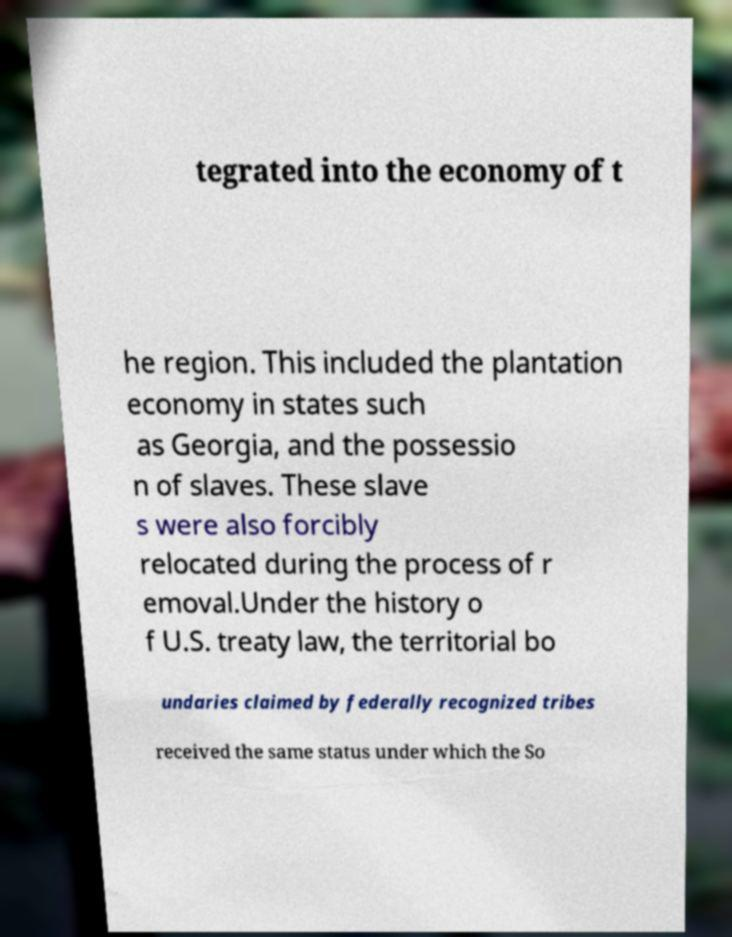Please read and relay the text visible in this image. What does it say? tegrated into the economy of t he region. This included the plantation economy in states such as Georgia, and the possessio n of slaves. These slave s were also forcibly relocated during the process of r emoval.Under the history o f U.S. treaty law, the territorial bo undaries claimed by federally recognized tribes received the same status under which the So 